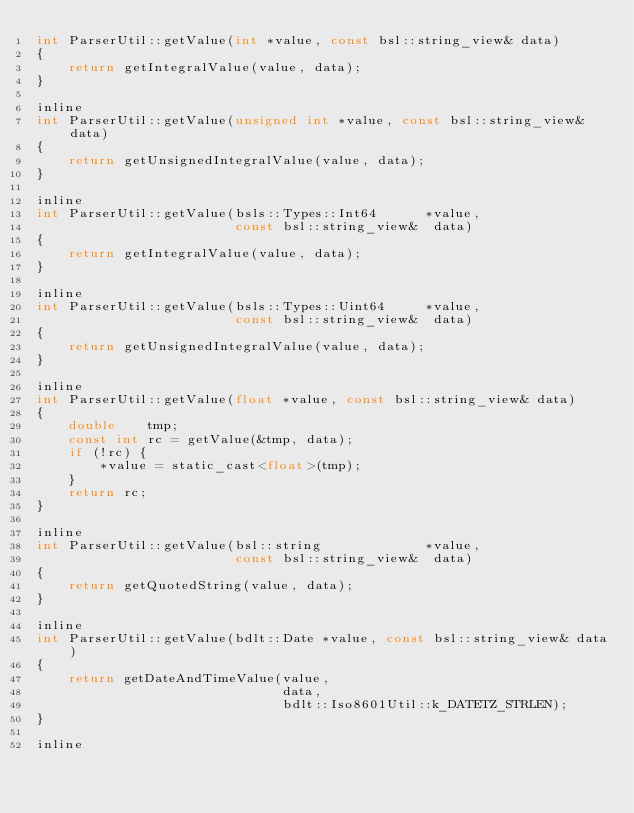Convert code to text. <code><loc_0><loc_0><loc_500><loc_500><_C_>int ParserUtil::getValue(int *value, const bsl::string_view& data)
{
    return getIntegralValue(value, data);
}

inline
int ParserUtil::getValue(unsigned int *value, const bsl::string_view& data)
{
    return getUnsignedIntegralValue(value, data);
}

inline
int ParserUtil::getValue(bsls::Types::Int64      *value,
                         const bsl::string_view&  data)
{
    return getIntegralValue(value, data);
}

inline
int ParserUtil::getValue(bsls::Types::Uint64     *value,
                         const bsl::string_view&  data)
{
    return getUnsignedIntegralValue(value, data);
}

inline
int ParserUtil::getValue(float *value, const bsl::string_view& data)
{
    double    tmp;
    const int rc = getValue(&tmp, data);
    if (!rc) {
        *value = static_cast<float>(tmp);
    }
    return rc;
}

inline
int ParserUtil::getValue(bsl::string             *value,
                         const bsl::string_view&  data)
{
    return getQuotedString(value, data);
}

inline
int ParserUtil::getValue(bdlt::Date *value, const bsl::string_view& data)
{
    return getDateAndTimeValue(value,
                               data,
                               bdlt::Iso8601Util::k_DATETZ_STRLEN);
}

inline</code> 